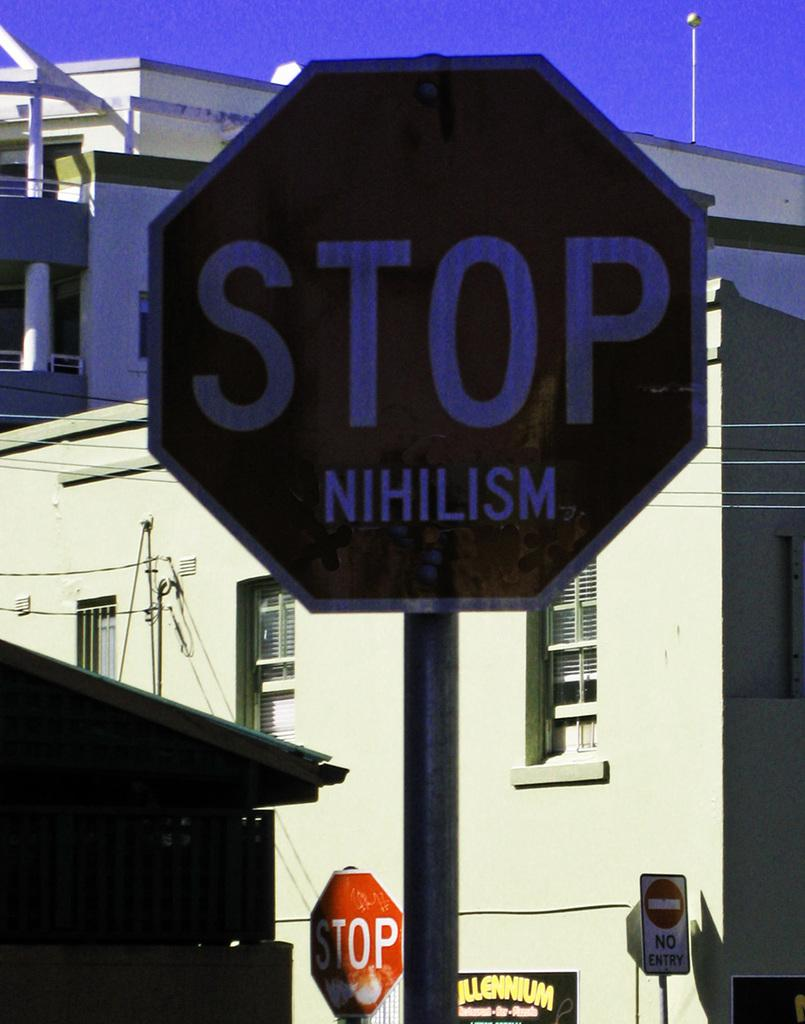Provide a one-sentence caption for the provided image. The stop sign has the word Nihilism written below it. 